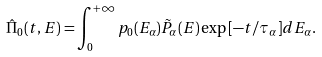<formula> <loc_0><loc_0><loc_500><loc_500>\hat { \Pi } _ { 0 } ( t , E ) = \int _ { 0 } ^ { + \infty } p _ { 0 } ( E _ { \alpha } ) \tilde { P } _ { \alpha } ( E ) \exp { \left [ - t / \tau _ { \alpha } \right ] } d E _ { \alpha } .</formula> 